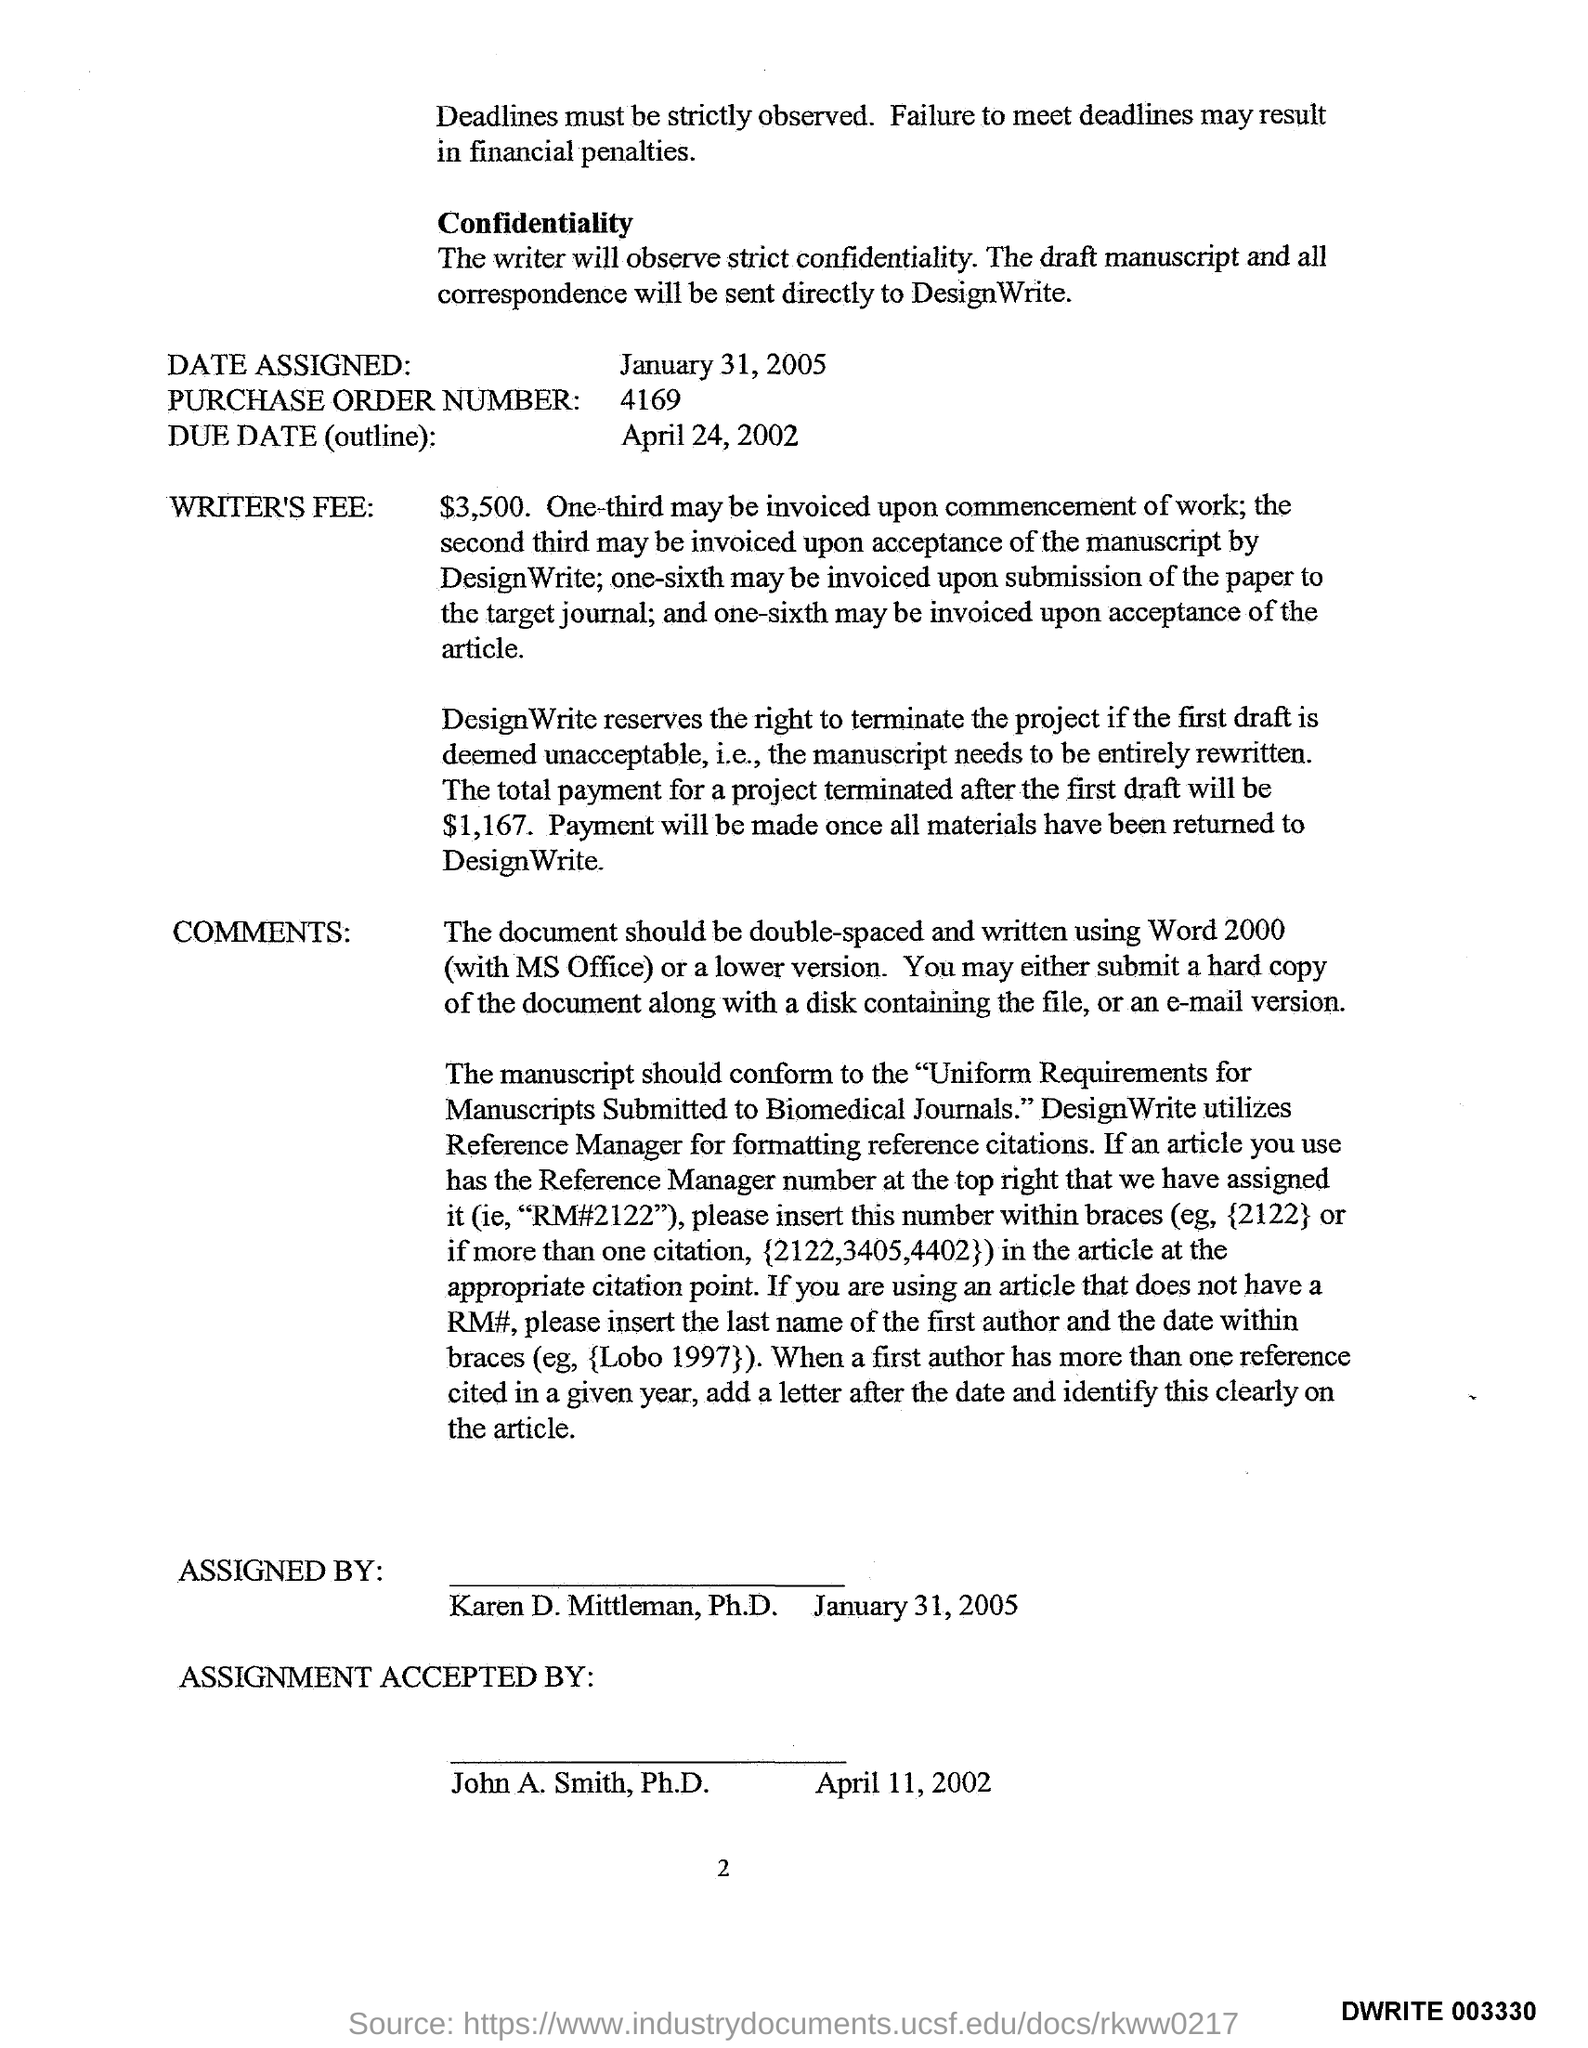List a handful of essential elements in this visual. The Writer's Fee is $3,500. The purchase order number contained in the document is 4169. The assignment was accepted by John A. Smith, Ph.D. on April 11, 2002. January 31, 2005 is the date assigned as per the document. John A. Smith has accepted the assignment. 